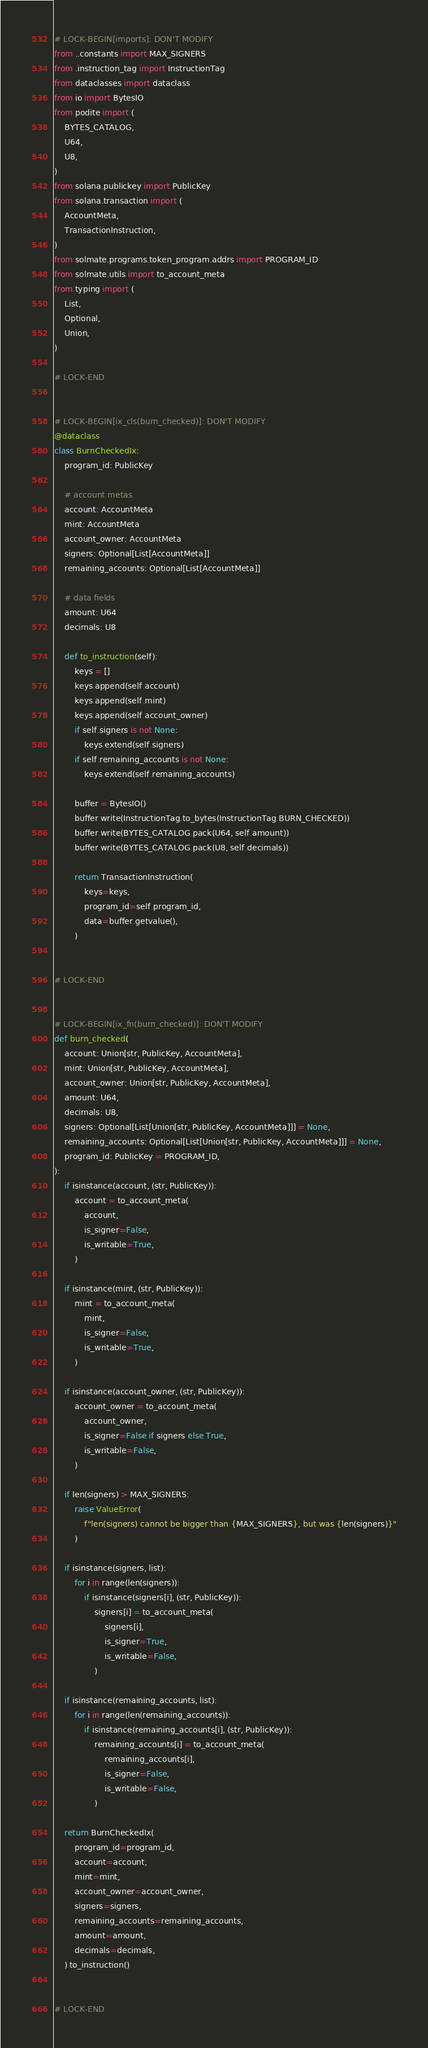<code> <loc_0><loc_0><loc_500><loc_500><_Python_># LOCK-BEGIN[imports]: DON'T MODIFY
from ..constants import MAX_SIGNERS
from .instruction_tag import InstructionTag
from dataclasses import dataclass
from io import BytesIO
from podite import (
    BYTES_CATALOG,
    U64,
    U8,
)
from solana.publickey import PublicKey
from solana.transaction import (
    AccountMeta,
    TransactionInstruction,
)
from solmate.programs.token_program.addrs import PROGRAM_ID
from solmate.utils import to_account_meta
from typing import (
    List,
    Optional,
    Union,
)

# LOCK-END


# LOCK-BEGIN[ix_cls(burn_checked)]: DON'T MODIFY
@dataclass
class BurnCheckedIx:
    program_id: PublicKey

    # account metas
    account: AccountMeta
    mint: AccountMeta
    account_owner: AccountMeta
    signers: Optional[List[AccountMeta]]
    remaining_accounts: Optional[List[AccountMeta]]

    # data fields
    amount: U64
    decimals: U8

    def to_instruction(self):
        keys = []
        keys.append(self.account)
        keys.append(self.mint)
        keys.append(self.account_owner)
        if self.signers is not None:
            keys.extend(self.signers)
        if self.remaining_accounts is not None:
            keys.extend(self.remaining_accounts)

        buffer = BytesIO()
        buffer.write(InstructionTag.to_bytes(InstructionTag.BURN_CHECKED))
        buffer.write(BYTES_CATALOG.pack(U64, self.amount))
        buffer.write(BYTES_CATALOG.pack(U8, self.decimals))

        return TransactionInstruction(
            keys=keys,
            program_id=self.program_id,
            data=buffer.getvalue(),
        )


# LOCK-END


# LOCK-BEGIN[ix_fn(burn_checked)]: DON'T MODIFY
def burn_checked(
    account: Union[str, PublicKey, AccountMeta],
    mint: Union[str, PublicKey, AccountMeta],
    account_owner: Union[str, PublicKey, AccountMeta],
    amount: U64,
    decimals: U8,
    signers: Optional[List[Union[str, PublicKey, AccountMeta]]] = None,
    remaining_accounts: Optional[List[Union[str, PublicKey, AccountMeta]]] = None,
    program_id: PublicKey = PROGRAM_ID,
):
    if isinstance(account, (str, PublicKey)):
        account = to_account_meta(
            account,
            is_signer=False,
            is_writable=True,
        )

    if isinstance(mint, (str, PublicKey)):
        mint = to_account_meta(
            mint,
            is_signer=False,
            is_writable=True,
        )

    if isinstance(account_owner, (str, PublicKey)):
        account_owner = to_account_meta(
            account_owner,
            is_signer=False if signers else True,
            is_writable=False,
        )

    if len(signers) > MAX_SIGNERS:
        raise ValueError(
            f"len(signers) cannot be bigger than {MAX_SIGNERS}, but was {len(signers)}"
        )

    if isinstance(signers, list):
        for i in range(len(signers)):
            if isinstance(signers[i], (str, PublicKey)):
                signers[i] = to_account_meta(
                    signers[i],
                    is_signer=True,
                    is_writable=False,
                )

    if isinstance(remaining_accounts, list):
        for i in range(len(remaining_accounts)):
            if isinstance(remaining_accounts[i], (str, PublicKey)):
                remaining_accounts[i] = to_account_meta(
                    remaining_accounts[i],
                    is_signer=False,
                    is_writable=False,
                )

    return BurnCheckedIx(
        program_id=program_id,
        account=account,
        mint=mint,
        account_owner=account_owner,
        signers=signers,
        remaining_accounts=remaining_accounts,
        amount=amount,
        decimals=decimals,
    ).to_instruction()


# LOCK-END
</code> 